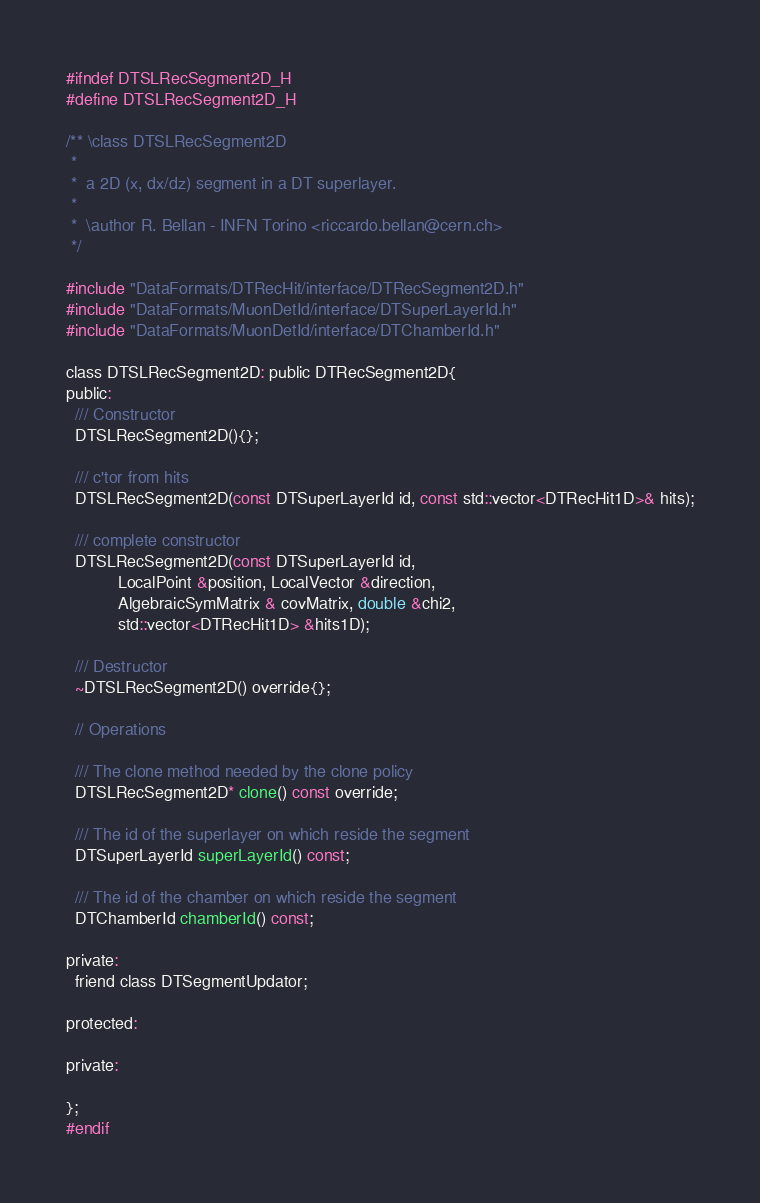Convert code to text. <code><loc_0><loc_0><loc_500><loc_500><_C_>#ifndef DTSLRecSegment2D_H
#define DTSLRecSegment2D_H

/** \class DTSLRecSegment2D
 *
 *  a 2D (x, dx/dz) segment in a DT superlayer.
 *
 *  \author R. Bellan - INFN Torino <riccardo.bellan@cern.ch>
 */

#include "DataFormats/DTRecHit/interface/DTRecSegment2D.h"
#include "DataFormats/MuonDetId/interface/DTSuperLayerId.h"
#include "DataFormats/MuonDetId/interface/DTChamberId.h"

class DTSLRecSegment2D: public DTRecSegment2D{
public:
  /// Constructor
  DTSLRecSegment2D(){};

  /// c'tor from hits
  DTSLRecSegment2D(const DTSuperLayerId id, const std::vector<DTRecHit1D>& hits);
  
  /// complete constructor
  DTSLRecSegment2D(const DTSuperLayerId id, 
		   LocalPoint &position, LocalVector &direction,
		   AlgebraicSymMatrix & covMatrix, double &chi2, 
		   std::vector<DTRecHit1D> &hits1D);

  /// Destructor
  ~DTSLRecSegment2D() override{};

  // Operations

  /// The clone method needed by the clone policy
  DTSLRecSegment2D* clone() const override;
  
  /// The id of the superlayer on which reside the segment
  DTSuperLayerId superLayerId() const;

  /// The id of the chamber on which reside the segment
  DTChamberId chamberId() const;

private:
  friend class DTSegmentUpdator;
  
protected:

private:

};
#endif

</code> 